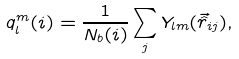Convert formula to latex. <formula><loc_0><loc_0><loc_500><loc_500>q _ { l } ^ { m } ( i ) = \frac { 1 } { N _ { b } ( i ) } \sum _ { j } Y _ { l m } ( \vec { \hat { r } } _ { i j } ) ,</formula> 